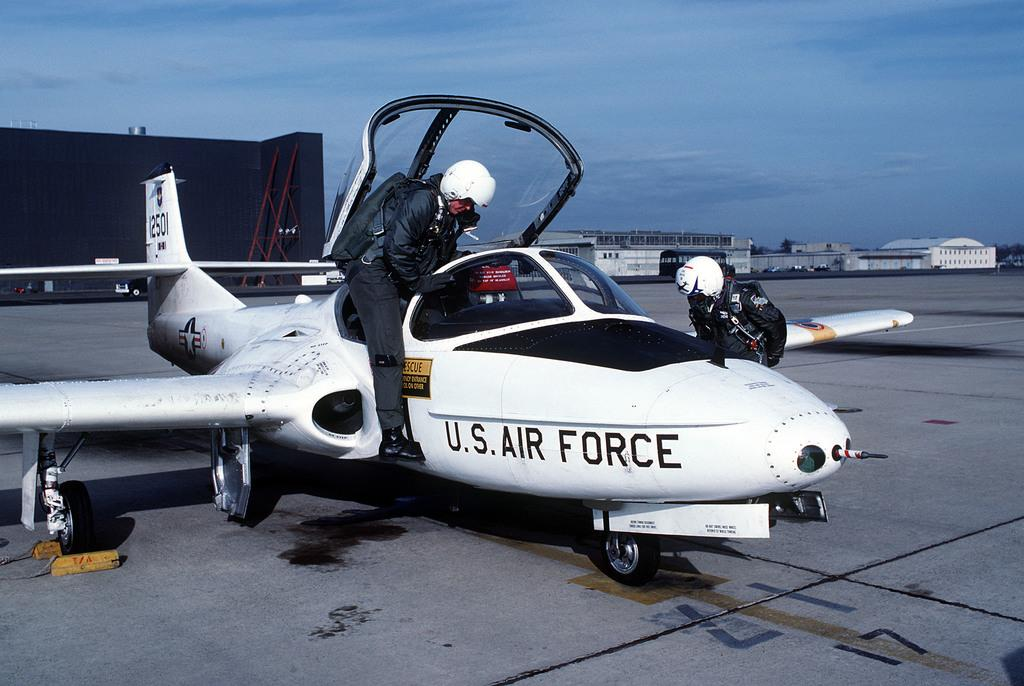<image>
Create a compact narrative representing the image presented. A US Air Force Pilot entering the cockpit. 